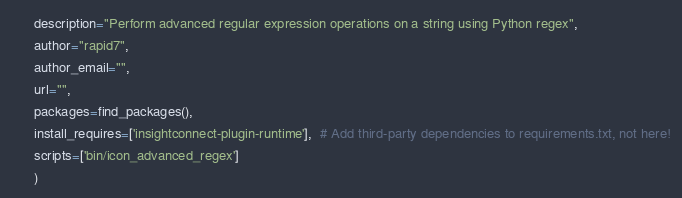<code> <loc_0><loc_0><loc_500><loc_500><_Python_>      description="Perform advanced regular expression operations on a string using Python regex",
      author="rapid7",
      author_email="",
      url="",
      packages=find_packages(),
      install_requires=['insightconnect-plugin-runtime'],  # Add third-party dependencies to requirements.txt, not here!
      scripts=['bin/icon_advanced_regex']
      )
</code> 